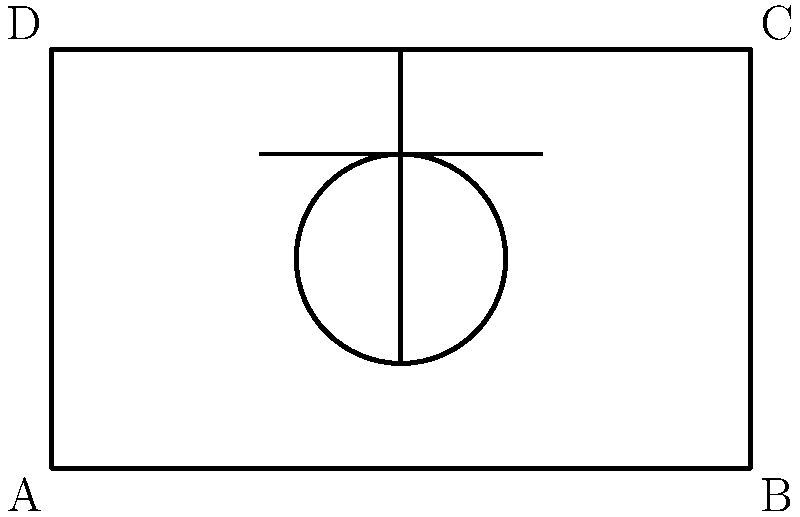In the diagram above, an Egyptian hieroglyph is carved within a rectangular frame on a temple wall. The frame has a width of 10 units and a height of 6 units. The ankh symbol extends from the bottom to the top of the frame, while the eye symbol is centered horizontally and vertically within the frame. If the eye symbol has a width that is 3/5 of the frame's width, what is the ratio of the area of the eye symbol to the area of the entire rectangular frame? Let's approach this step-by-step:

1) First, we need to calculate the area of the rectangular frame:
   Area of frame = width × height = 10 × 6 = 60 square units

2) Now, let's focus on the eye symbol:
   - We're told its width is 3/5 of the frame's width
   - Frame width = 10 units
   - Eye width = 3/5 × 10 = 6 units

3) The eye symbol appears to be circular. In a circle, the width is equal to the diameter. So:
   Diameter of eye = 6 units
   Radius of eye = 6/2 = 3 units

4) The area of a circle is given by the formula $A = \pi r^2$:
   Area of eye = $\pi × 3^2 = 9\pi$ square units

5) Now we can calculate the ratio of the eye's area to the frame's area:
   Ratio = Area of eye / Area of frame
         = $9\pi / 60$

6) This can be simplified to:
   Ratio = $3\pi / 20$

Therefore, the ratio of the area of the eye symbol to the area of the entire rectangular frame is $3\pi : 20$.
Answer: $3\pi : 20$ 